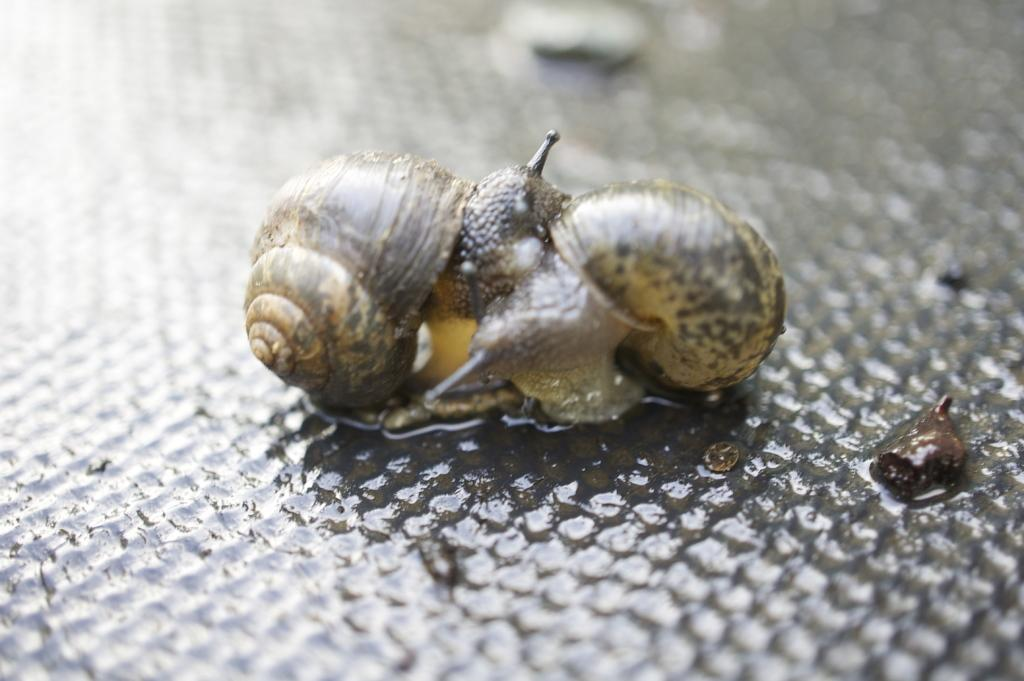What type of animal is in the image? There is a snail in the image. What is the snail doing in the image? The snail is coming out from its shell. What type of pencil is the snail using to draw in the image? There is no pencil present in the image, and snails do not use pencils to draw. 